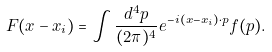Convert formula to latex. <formula><loc_0><loc_0><loc_500><loc_500>F ( x - x _ { i } ) = \int \frac { d ^ { 4 } p } { ( 2 \pi ) ^ { 4 } } e ^ { - i ( x - x _ { i } ) \cdot p } f ( p ) .</formula> 